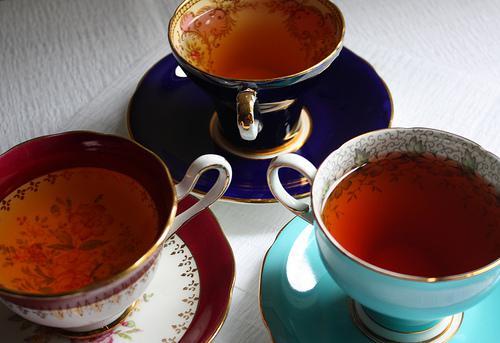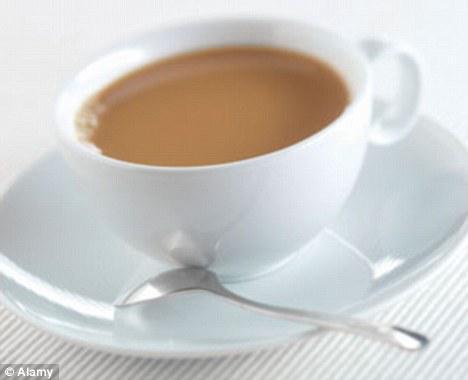The first image is the image on the left, the second image is the image on the right. Examine the images to the left and right. Is the description "An image shows a trio of gold-trimmed cup and saucer sets, including one that is robin's egg blue." accurate? Answer yes or no. Yes. The first image is the image on the left, the second image is the image on the right. Assess this claim about the two images: "Exactly four different cups with matching saucers are shown, three in one image and one in a second image.". Correct or not? Answer yes or no. Yes. 